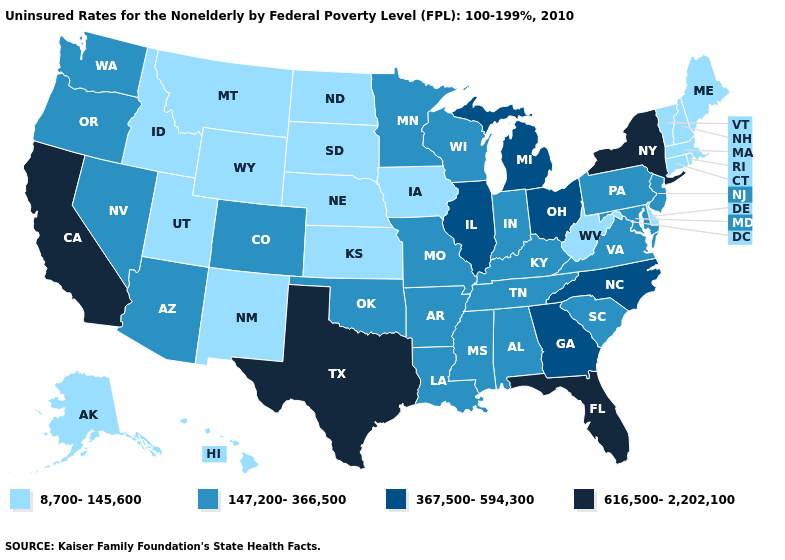What is the value of West Virginia?
Quick response, please. 8,700-145,600. What is the value of Washington?
Be succinct. 147,200-366,500. Does Indiana have the highest value in the USA?
Answer briefly. No. What is the value of Virginia?
Write a very short answer. 147,200-366,500. What is the lowest value in the USA?
Quick response, please. 8,700-145,600. What is the lowest value in the Northeast?
Quick response, please. 8,700-145,600. How many symbols are there in the legend?
Keep it brief. 4. What is the value of Utah?
Answer briefly. 8,700-145,600. Does the map have missing data?
Answer briefly. No. Name the states that have a value in the range 616,500-2,202,100?
Answer briefly. California, Florida, New York, Texas. Name the states that have a value in the range 616,500-2,202,100?
Quick response, please. California, Florida, New York, Texas. Name the states that have a value in the range 616,500-2,202,100?
Be succinct. California, Florida, New York, Texas. What is the value of Texas?
Keep it brief. 616,500-2,202,100. Which states have the highest value in the USA?
Write a very short answer. California, Florida, New York, Texas. What is the highest value in the MidWest ?
Write a very short answer. 367,500-594,300. 